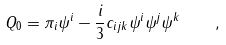<formula> <loc_0><loc_0><loc_500><loc_500>Q _ { 0 } = \pi _ { i } \psi ^ { i } - \frac { i } { 3 } c _ { i j k } \psi ^ { i } \psi ^ { j } \psi ^ { k } \quad ,</formula> 